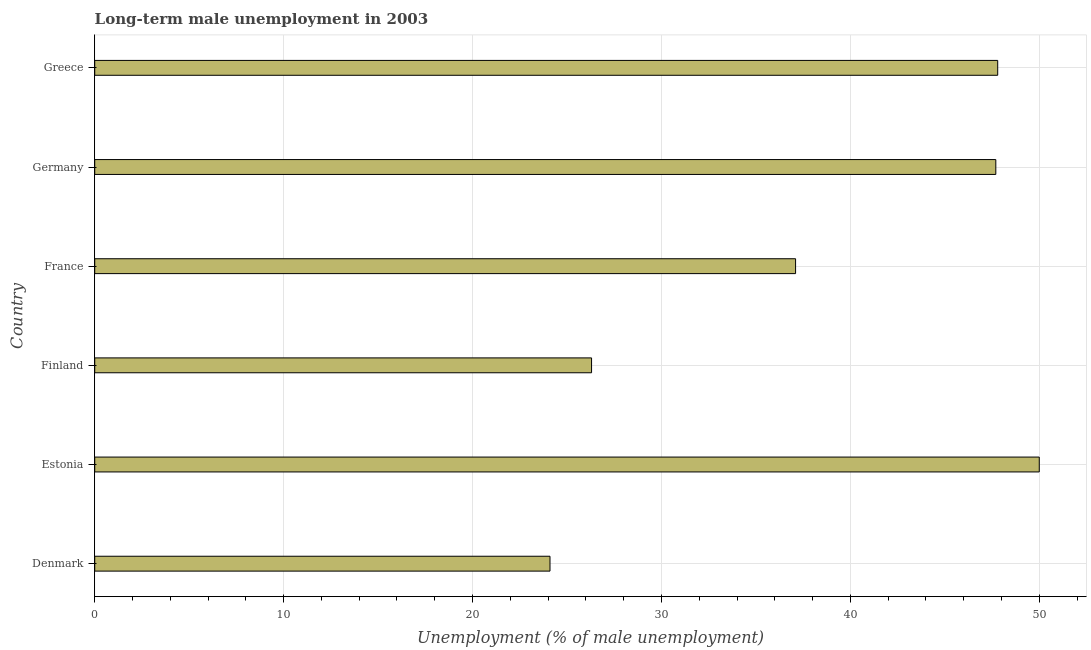Does the graph contain any zero values?
Keep it short and to the point. No. What is the title of the graph?
Make the answer very short. Long-term male unemployment in 2003. What is the label or title of the X-axis?
Give a very brief answer. Unemployment (% of male unemployment). Across all countries, what is the maximum long-term male unemployment?
Offer a terse response. 50. Across all countries, what is the minimum long-term male unemployment?
Provide a succinct answer. 24.1. In which country was the long-term male unemployment maximum?
Your answer should be compact. Estonia. In which country was the long-term male unemployment minimum?
Your answer should be compact. Denmark. What is the sum of the long-term male unemployment?
Provide a short and direct response. 233. What is the difference between the long-term male unemployment in Denmark and Estonia?
Your answer should be compact. -25.9. What is the average long-term male unemployment per country?
Offer a very short reply. 38.83. What is the median long-term male unemployment?
Provide a succinct answer. 42.4. What is the ratio of the long-term male unemployment in Estonia to that in Greece?
Your response must be concise. 1.05. Is the long-term male unemployment in France less than that in Germany?
Provide a short and direct response. Yes. What is the difference between the highest and the second highest long-term male unemployment?
Give a very brief answer. 2.2. Is the sum of the long-term male unemployment in Denmark and Germany greater than the maximum long-term male unemployment across all countries?
Provide a succinct answer. Yes. What is the difference between the highest and the lowest long-term male unemployment?
Provide a succinct answer. 25.9. In how many countries, is the long-term male unemployment greater than the average long-term male unemployment taken over all countries?
Your answer should be compact. 3. How many bars are there?
Provide a short and direct response. 6. What is the difference between two consecutive major ticks on the X-axis?
Keep it short and to the point. 10. What is the Unemployment (% of male unemployment) in Denmark?
Keep it short and to the point. 24.1. What is the Unemployment (% of male unemployment) in Estonia?
Keep it short and to the point. 50. What is the Unemployment (% of male unemployment) of Finland?
Offer a very short reply. 26.3. What is the Unemployment (% of male unemployment) of France?
Provide a succinct answer. 37.1. What is the Unemployment (% of male unemployment) of Germany?
Give a very brief answer. 47.7. What is the Unemployment (% of male unemployment) of Greece?
Make the answer very short. 47.8. What is the difference between the Unemployment (% of male unemployment) in Denmark and Estonia?
Your answer should be compact. -25.9. What is the difference between the Unemployment (% of male unemployment) in Denmark and Finland?
Your answer should be very brief. -2.2. What is the difference between the Unemployment (% of male unemployment) in Denmark and Germany?
Your response must be concise. -23.6. What is the difference between the Unemployment (% of male unemployment) in Denmark and Greece?
Ensure brevity in your answer.  -23.7. What is the difference between the Unemployment (% of male unemployment) in Estonia and Finland?
Your response must be concise. 23.7. What is the difference between the Unemployment (% of male unemployment) in Estonia and France?
Give a very brief answer. 12.9. What is the difference between the Unemployment (% of male unemployment) in Estonia and Germany?
Ensure brevity in your answer.  2.3. What is the difference between the Unemployment (% of male unemployment) in Finland and Germany?
Provide a short and direct response. -21.4. What is the difference between the Unemployment (% of male unemployment) in Finland and Greece?
Give a very brief answer. -21.5. What is the difference between the Unemployment (% of male unemployment) in France and Germany?
Your response must be concise. -10.6. What is the difference between the Unemployment (% of male unemployment) in France and Greece?
Provide a short and direct response. -10.7. What is the difference between the Unemployment (% of male unemployment) in Germany and Greece?
Ensure brevity in your answer.  -0.1. What is the ratio of the Unemployment (% of male unemployment) in Denmark to that in Estonia?
Your answer should be compact. 0.48. What is the ratio of the Unemployment (% of male unemployment) in Denmark to that in Finland?
Offer a terse response. 0.92. What is the ratio of the Unemployment (% of male unemployment) in Denmark to that in France?
Your answer should be very brief. 0.65. What is the ratio of the Unemployment (% of male unemployment) in Denmark to that in Germany?
Offer a very short reply. 0.51. What is the ratio of the Unemployment (% of male unemployment) in Denmark to that in Greece?
Keep it short and to the point. 0.5. What is the ratio of the Unemployment (% of male unemployment) in Estonia to that in Finland?
Make the answer very short. 1.9. What is the ratio of the Unemployment (% of male unemployment) in Estonia to that in France?
Give a very brief answer. 1.35. What is the ratio of the Unemployment (% of male unemployment) in Estonia to that in Germany?
Offer a terse response. 1.05. What is the ratio of the Unemployment (% of male unemployment) in Estonia to that in Greece?
Provide a short and direct response. 1.05. What is the ratio of the Unemployment (% of male unemployment) in Finland to that in France?
Make the answer very short. 0.71. What is the ratio of the Unemployment (% of male unemployment) in Finland to that in Germany?
Offer a terse response. 0.55. What is the ratio of the Unemployment (% of male unemployment) in Finland to that in Greece?
Provide a short and direct response. 0.55. What is the ratio of the Unemployment (% of male unemployment) in France to that in Germany?
Offer a terse response. 0.78. What is the ratio of the Unemployment (% of male unemployment) in France to that in Greece?
Make the answer very short. 0.78. What is the ratio of the Unemployment (% of male unemployment) in Germany to that in Greece?
Give a very brief answer. 1. 